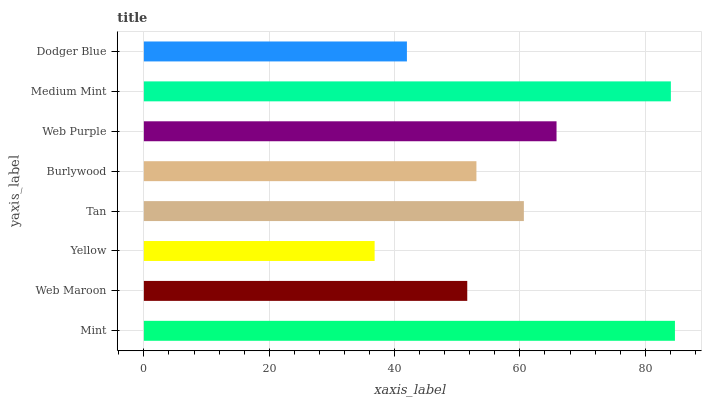Is Yellow the minimum?
Answer yes or no. Yes. Is Mint the maximum?
Answer yes or no. Yes. Is Web Maroon the minimum?
Answer yes or no. No. Is Web Maroon the maximum?
Answer yes or no. No. Is Mint greater than Web Maroon?
Answer yes or no. Yes. Is Web Maroon less than Mint?
Answer yes or no. Yes. Is Web Maroon greater than Mint?
Answer yes or no. No. Is Mint less than Web Maroon?
Answer yes or no. No. Is Tan the high median?
Answer yes or no. Yes. Is Burlywood the low median?
Answer yes or no. Yes. Is Yellow the high median?
Answer yes or no. No. Is Web Maroon the low median?
Answer yes or no. No. 